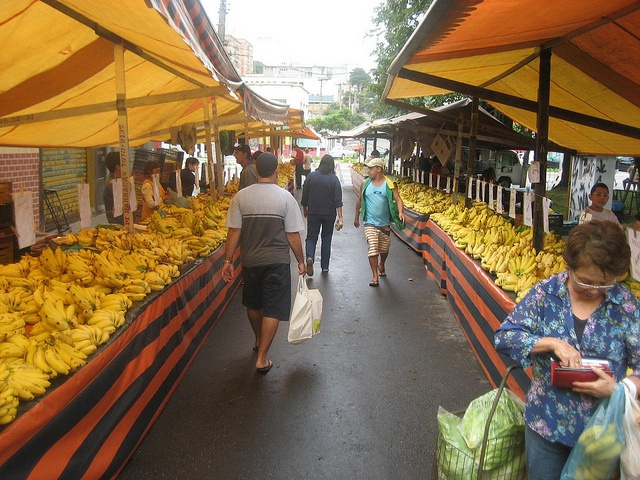Describe the objects in this image and their specific colors. I can see banana in orange and olive tones, people in orange, gray, darkblue, and black tones, people in orange, black, maroon, darkgray, and gray tones, people in orange, gray, darkgray, and maroon tones, and people in orange, gray, and black tones in this image. 